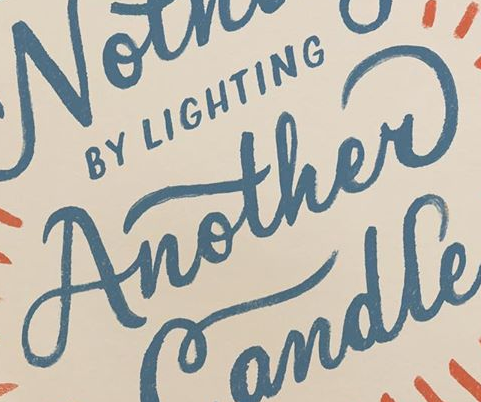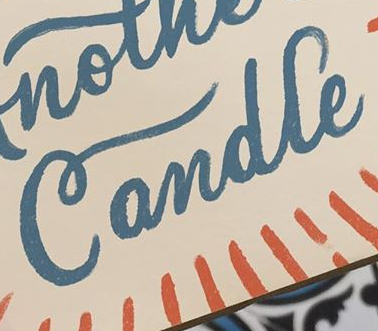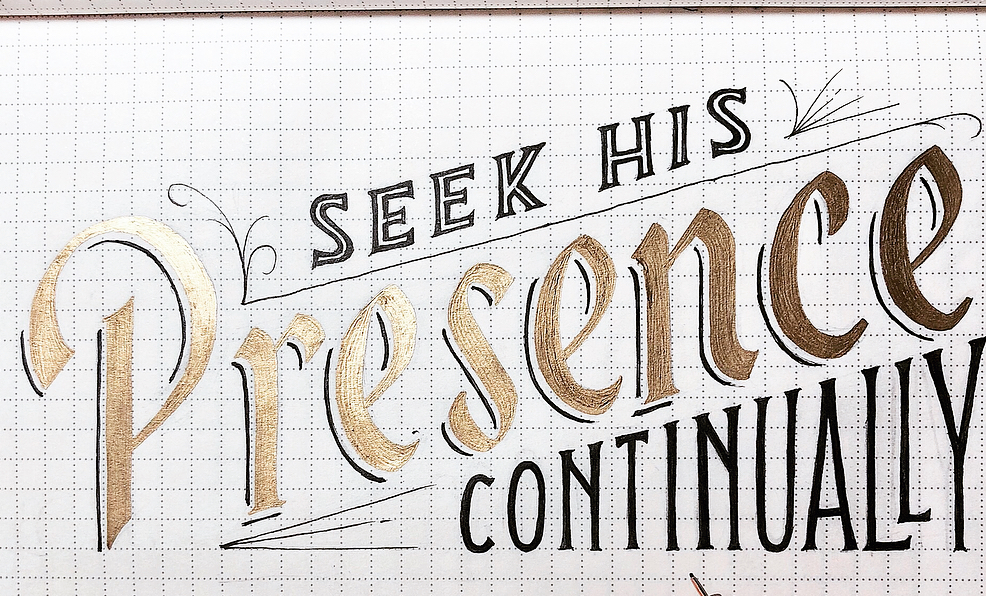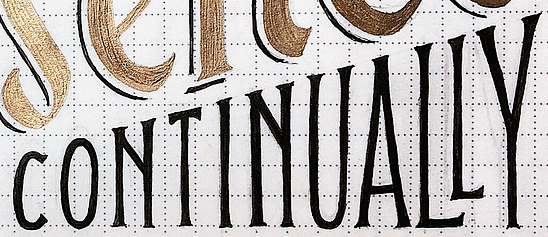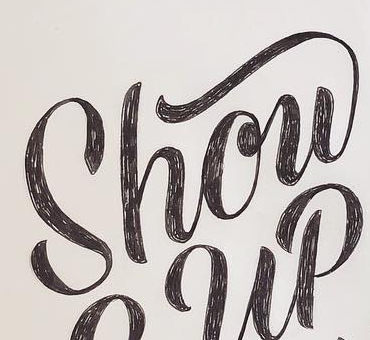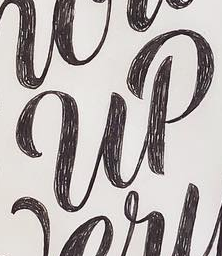Read the text content from these images in order, separated by a semicolon. Another; Candle; Presence; CONTINUALLY; Show; up 